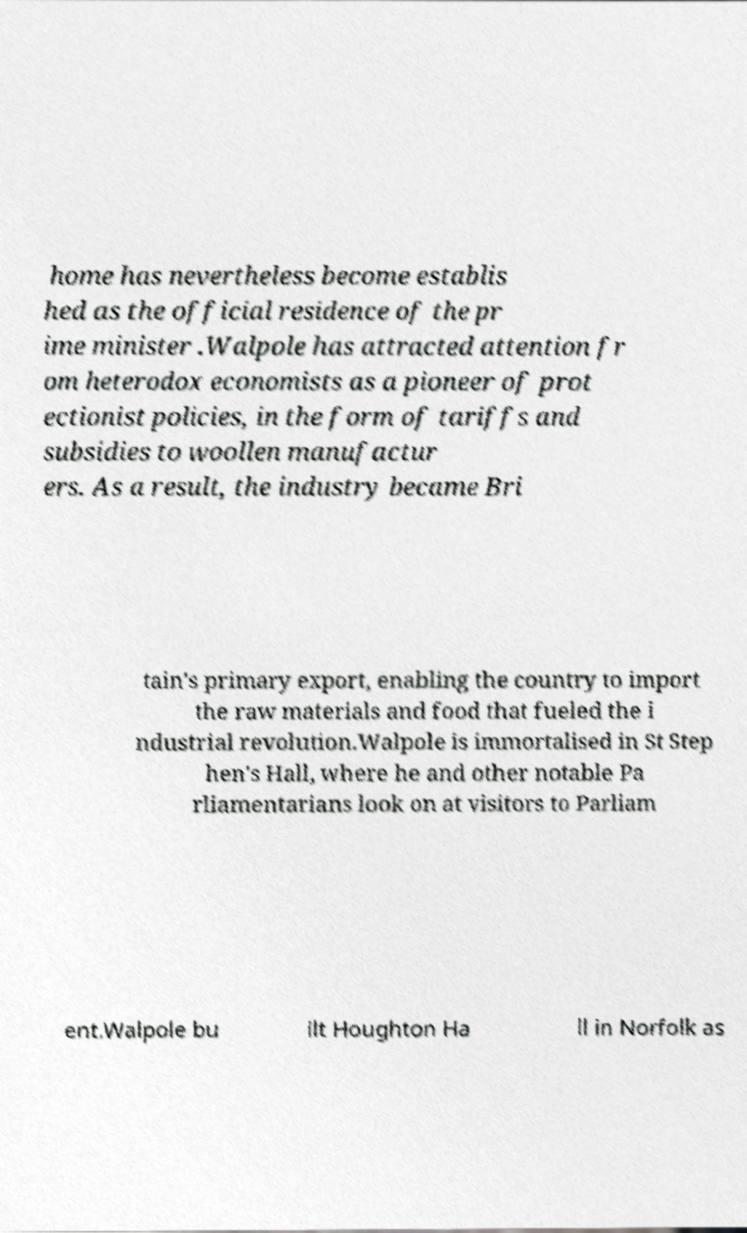Please identify and transcribe the text found in this image. home has nevertheless become establis hed as the official residence of the pr ime minister .Walpole has attracted attention fr om heterodox economists as a pioneer of prot ectionist policies, in the form of tariffs and subsidies to woollen manufactur ers. As a result, the industry became Bri tain's primary export, enabling the country to import the raw materials and food that fueled the i ndustrial revolution.Walpole is immortalised in St Step hen's Hall, where he and other notable Pa rliamentarians look on at visitors to Parliam ent.Walpole bu ilt Houghton Ha ll in Norfolk as 